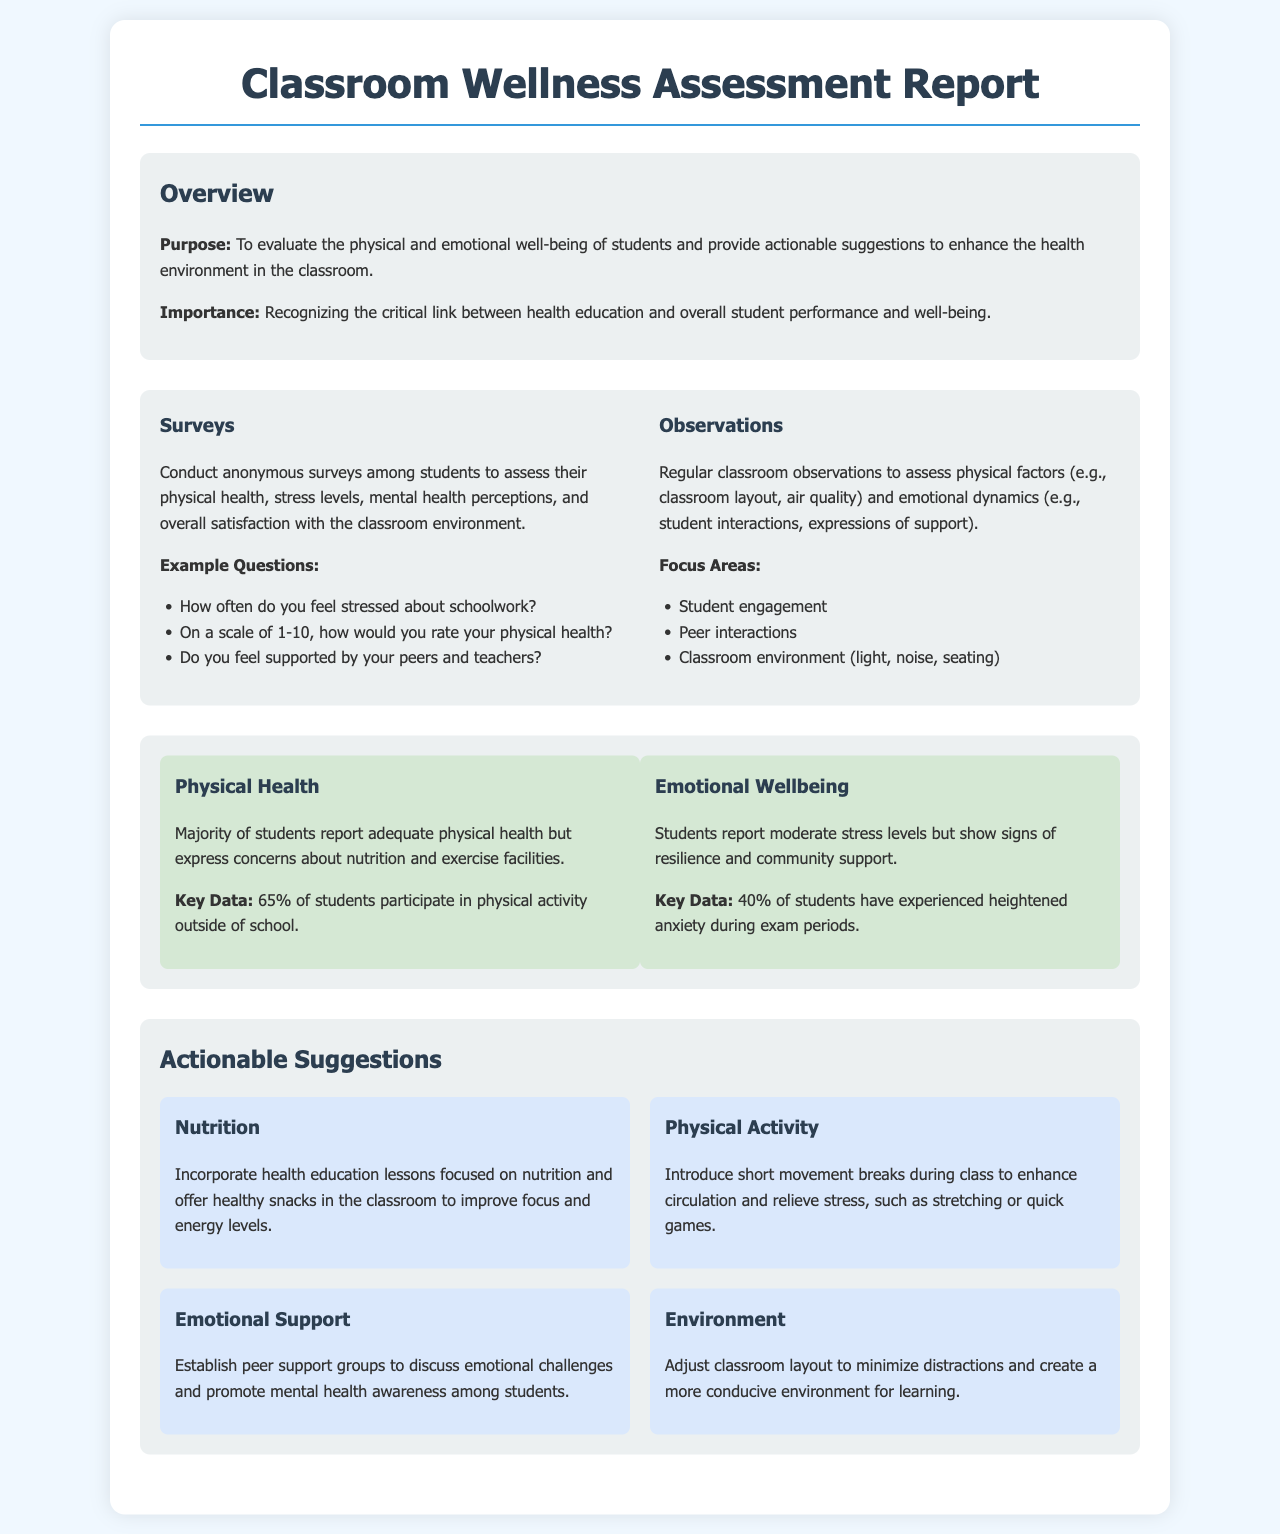What is the purpose of the report? The purpose of the report is to evaluate the physical and emotional well-being of students and provide actionable suggestions to enhance the health environment in the classroom.
Answer: To evaluate the physical and emotional well-being of students What percentage of students participate in physical activity outside of school? The document states that 65% of students participate in physical activity outside of school.
Answer: 65% What topic is suggested to be incorporated into health education lessons? The document suggests incorporating health education lessons focused on nutrition.
Answer: Nutrition What is one major concern reported regarding students' physical health? The document mentions concerns about nutrition and exercise facilities.
Answer: Nutrition and exercise facilities How many students have experienced heightened anxiety during exam periods? The key data in the document indicates that 40% of students have experienced heightened anxiety during exam periods.
Answer: 40% What type of support groups are suggested in the report? The document recommends establishing peer support groups to discuss emotional challenges.
Answer: Peer support groups What is a suggested action to improve students' emotional wellbeing? The report suggests promoting mental health awareness among students through support groups.
Answer: Promote mental health awareness What action is recommended for physical activity during class? The document recommends introducing short movement breaks during class to enhance circulation and relieve stress.
Answer: Short movement breaks 